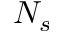Convert formula to latex. <formula><loc_0><loc_0><loc_500><loc_500>N _ { s }</formula> 